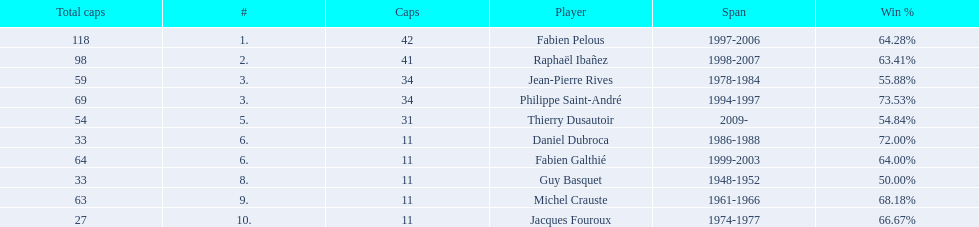How many players have spans above three years? 6. 